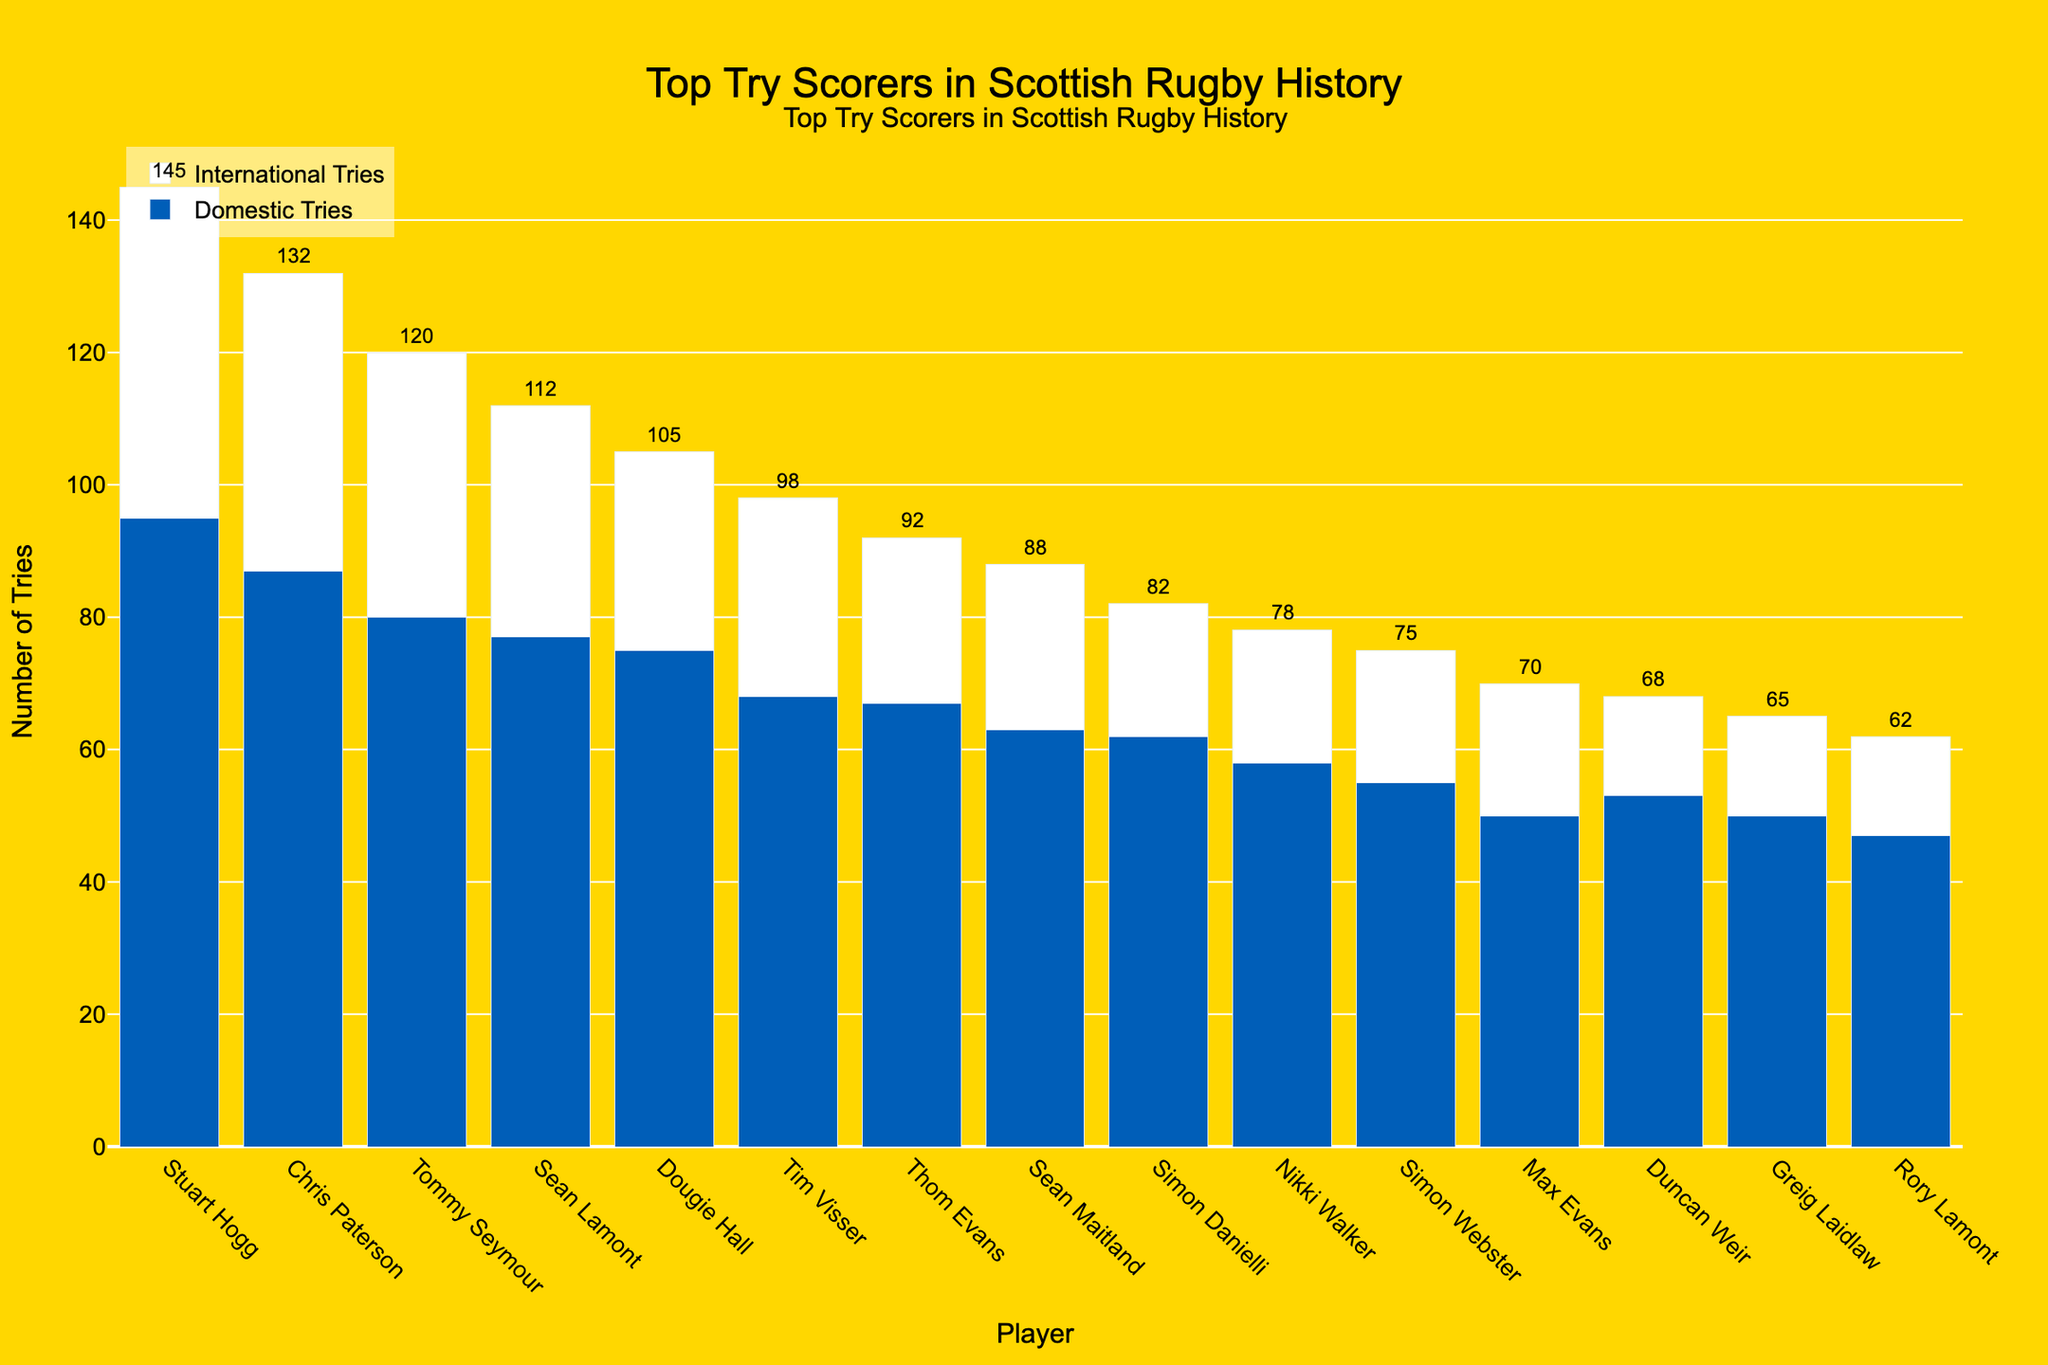Which player has the highest number of total tries? Stuart Hogg has the highest total tries. Look for the player with the tallest combined bar (domestic + international tries) and find the corresponding player's name.
Answer: Stuart Hogg Who scored more domestic tries, Chris Paterson or Tommy Seymour? Compare the heights of the domestic tries bars for Chris Paterson and Tommy Seymour. The taller bar corresponds to Chris Paterson.
Answer: Chris Paterson What is the total number of tries scored by Sean Lamont in both domestic and international matches? To get the total, sum the domestic and international tries for Sean Lamont from the figure: Domestic (77) + International (35).
Answer: 112 Which player has the smallest difference between domestic and international tries? Calculate the difference between domestic and international tries for each player and identify the smallest difference. For Rory Lamont: 47 domestic - 15 international = 32; For Simon Danielli: 62 domestic - 20 international = 42, and so on. The smallest difference is for Dougie Hall: 75 domestic - 30 international = 45.
Answer: Dougie Hall Among the players listed, who scored fewer international tries, Max Evans or Greig Laidlaw? Compare the international tries bars for Max Evans and Greig Laidlaw. Max Evans has 20 while Greig Laidlaw has 15.
Answer: Greig Laidlaw What is the combined total number of domestic tries scored by the top three try scorers? Sum the domestic tries of the top three players: Stuart Hogg (95), Chris Paterson (87), and Tommy Seymour (80). The total is 95 + 87 + 80 = 262.
Answer: 262 Which player has an even distribution of tries between domestic and international matches? Check the bars of each player to see whose domestic and international tries are closest in number. Thom Evans has domestic (67) and international (25), difference = 42; Sean Maitland has domestic (63) and international (25), difference = 38; Rory Lamont has domestic (47) and international (15), difference = 32. Rory Lamont has the least difference but it is still significant. No player has an exactly even distribution.
Answer: None How many players have scored 20 or more international tries? Count the number of bars in the international tries category that are 20 or taller: Stuart Hogg, Chris Paterson, Tommy Seymour, Sean Lamont, Dougie Hall, Tim Visser, Thom Evans, Sean Maitland, Simon Danielli, Nikki Walker, Simon Webster, Max Evans (12 players).
Answer: 12 Which player has the least total number of tries? Identify the player with the shortest combined bar (domestic + international tries) in the chart. This is Rory Lamont.
Answer: Rory Lamont 